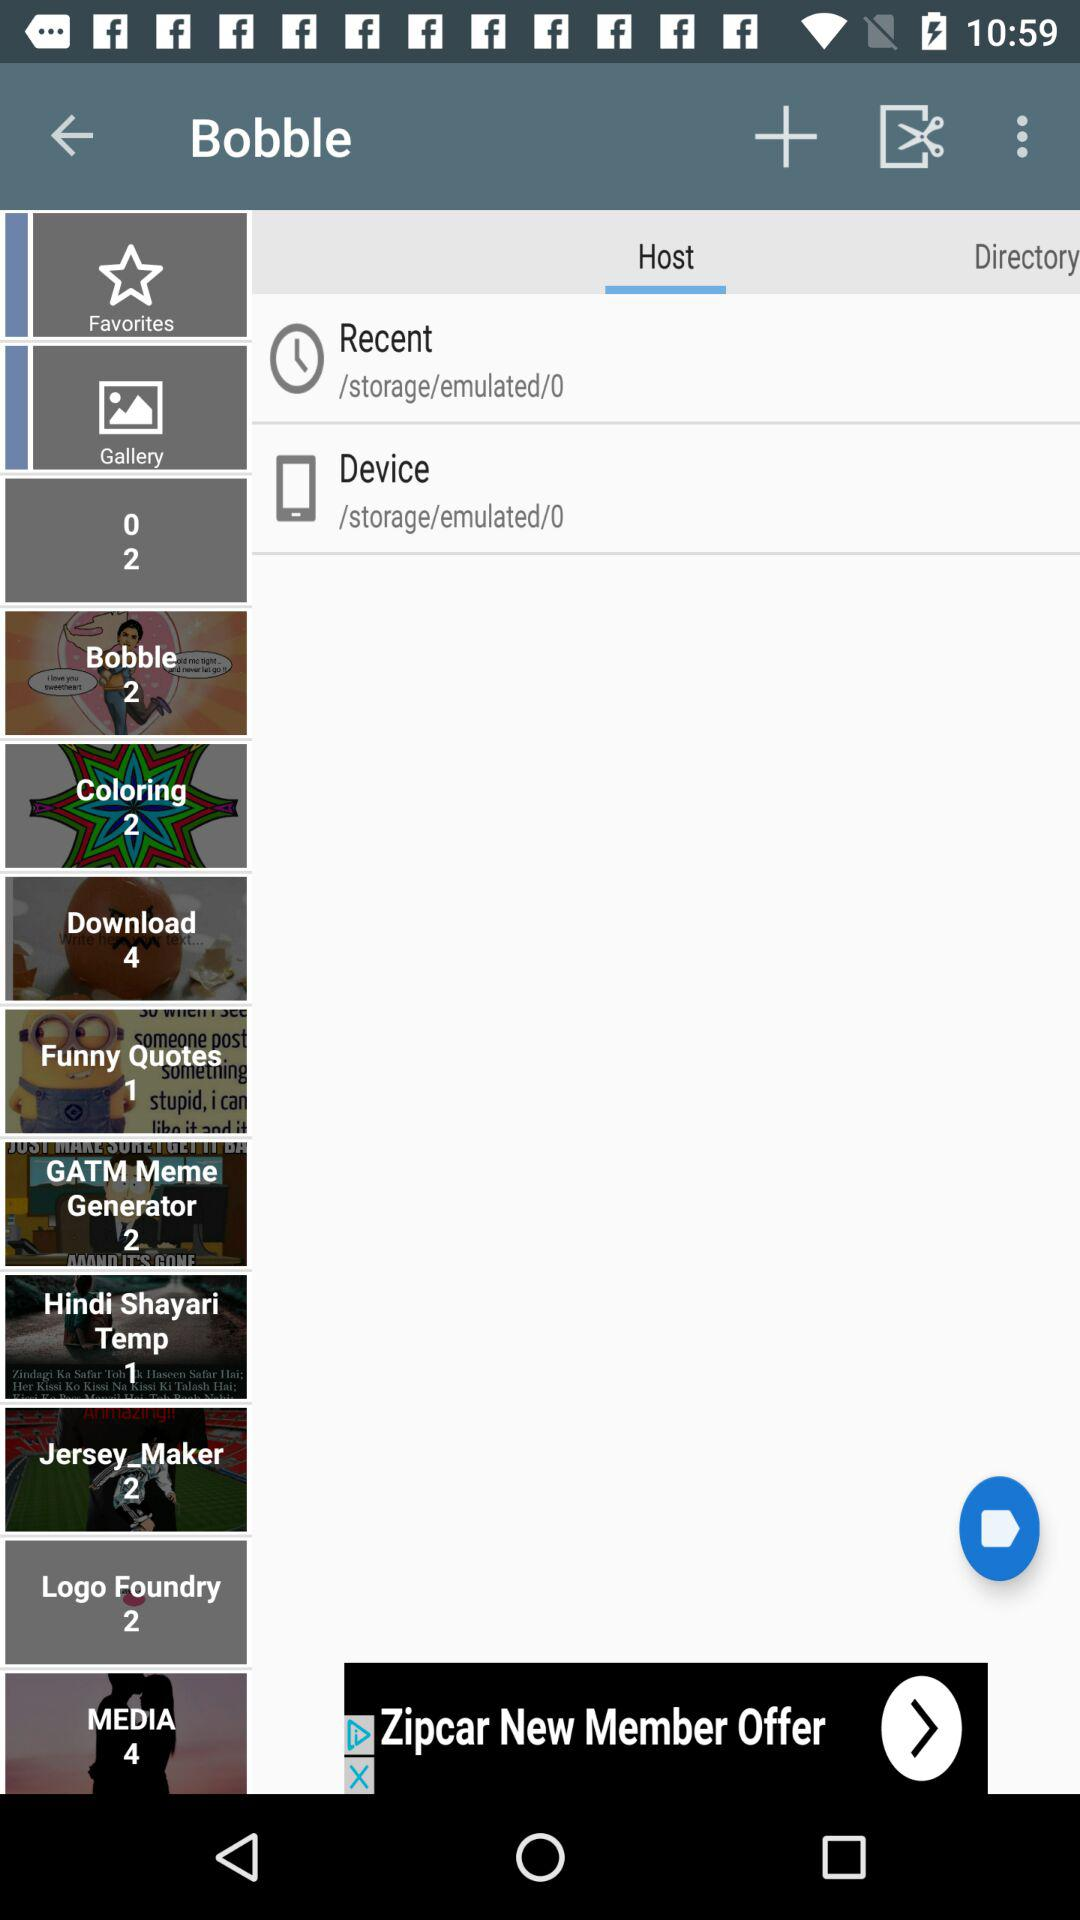What is the number of funny quotes? The number of funny quotes is 1. 